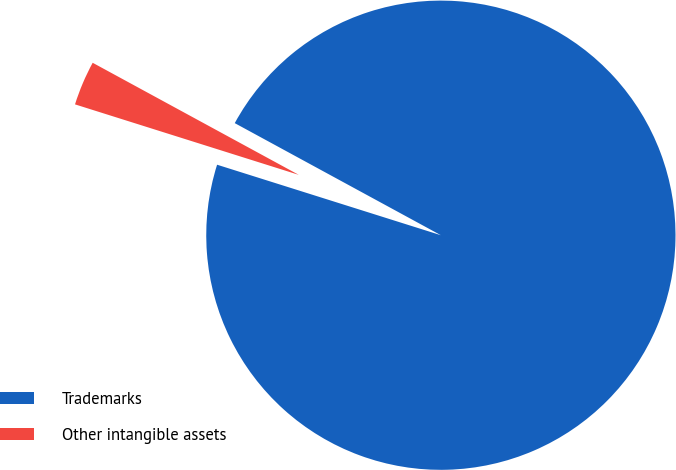Convert chart to OTSL. <chart><loc_0><loc_0><loc_500><loc_500><pie_chart><fcel>Trademarks<fcel>Other intangible assets<nl><fcel>96.93%<fcel>3.07%<nl></chart> 